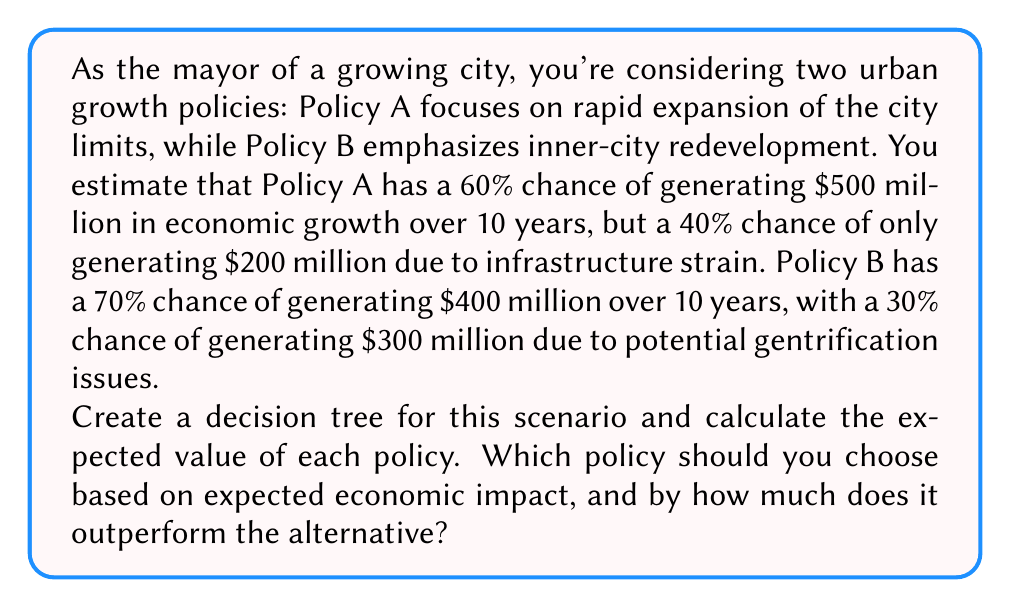Provide a solution to this math problem. Let's approach this step-by-step:

1. First, let's create the decision tree:

[asy]
unitsize(1cm);

draw((0,0)--(2,1), arrow=Arrow());
draw((0,0)--(2,-1), arrow=Arrow());

draw((2,1)--(4,1.5), arrow=Arrow());
draw((2,1)--(4,0.5), arrow=Arrow());

draw((2,-1)--(4,-0.5), arrow=Arrow());
draw((2,-1)--(4,-1.5), arrow=Arrow());

label("Policy A", (1,0.7));
label("Policy B", (1,-0.7));

label("60%", (3,1.4));
label("40%", (3,0.6));

label("70%", (3,-0.6));
label("30%", (3,-1.4));

label("$500M", (4.5,1.5));
label("$200M", (4.5,0.5));

label("$400M", (4.5,-0.5));
label("$300M", (4.5,-1.5));
[/asy]

2. Now, let's calculate the expected value for each policy:

   For Policy A:
   $$ EV(A) = 0.60 \times \$500M + 0.40 \times \$200M $$
   $$ EV(A) = \$300M + \$80M = \$380M $$

   For Policy B:
   $$ EV(B) = 0.70 \times \$400M + 0.30 \times \$300M $$
   $$ EV(B) = \$280M + \$90M = \$370M $$

3. To determine which policy outperforms the other and by how much:
   $$ \text{Difference} = EV(A) - EV(B) = \$380M - \$370M = \$10M $$
Answer: Policy A should be chosen based on expected economic impact, as it outperforms Policy B by $10 million in expected value over the 10-year period. 